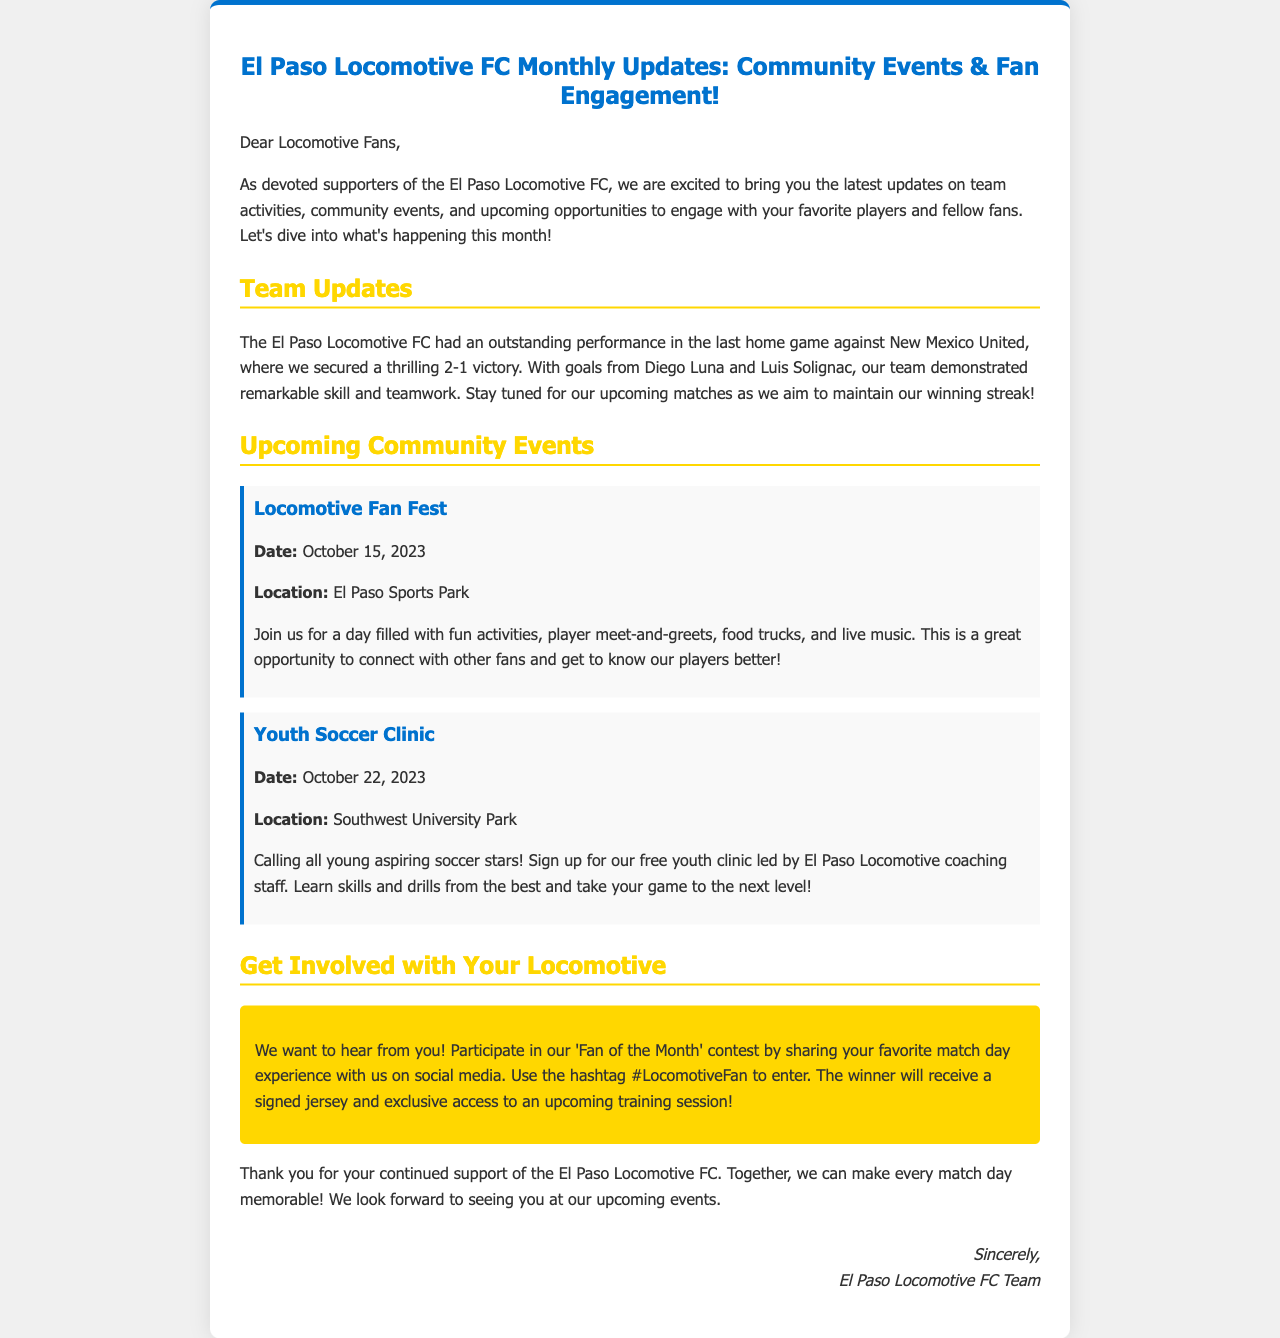what was the result of the last home game? The document states that the El Paso Locomotive FC secured a thrilling victory against New Mexico United with a score of 2-1.
Answer: 2-1 who scored the goals in the last home game? The document mentions that Diego Luna and Luis Solignac scored in the last home game against New Mexico United.
Answer: Diego Luna and Luis Solignac when is the Locomotive Fan Fest taking place? The date for the Locomotive Fan Fest is provided in the document as October 15, 2023.
Answer: October 15, 2023 where is the Youth Soccer Clinic being held? The location of the Youth Soccer Clinic is indicated in the document as Southwest University Park.
Answer: Southwest University Park what is the prize for the 'Fan of the Month' contest? The document states that the winner of the 'Fan of the Month' contest will receive a signed jersey and exclusive access to an upcoming training session.
Answer: signed jersey and exclusive access to an upcoming training session why should fans attend the Locomotive Fan Fest? The document highlights that the event will include fun activities, player meet-and-greets, food trucks, and live music, providing a great chance for fans to connect.
Answer: activities, player meet-and-greets, food trucks, and live music who is leading the Youth Soccer Clinic? The document specifies that the Youth Soccer Clinic will be led by the El Paso Locomotive coaching staff.
Answer: El Paso Locomotive coaching staff what hashtag should fans use for the contest? The document instructs fans to use the hashtag #LocomotiveFan to participate in the contest.
Answer: #LocomotiveFan how does the El Paso Locomotive FC communicate with fans? It is mentioned in the document that fans are encouraged to share their experiences on social media to engage with the team.
Answer: through social media 